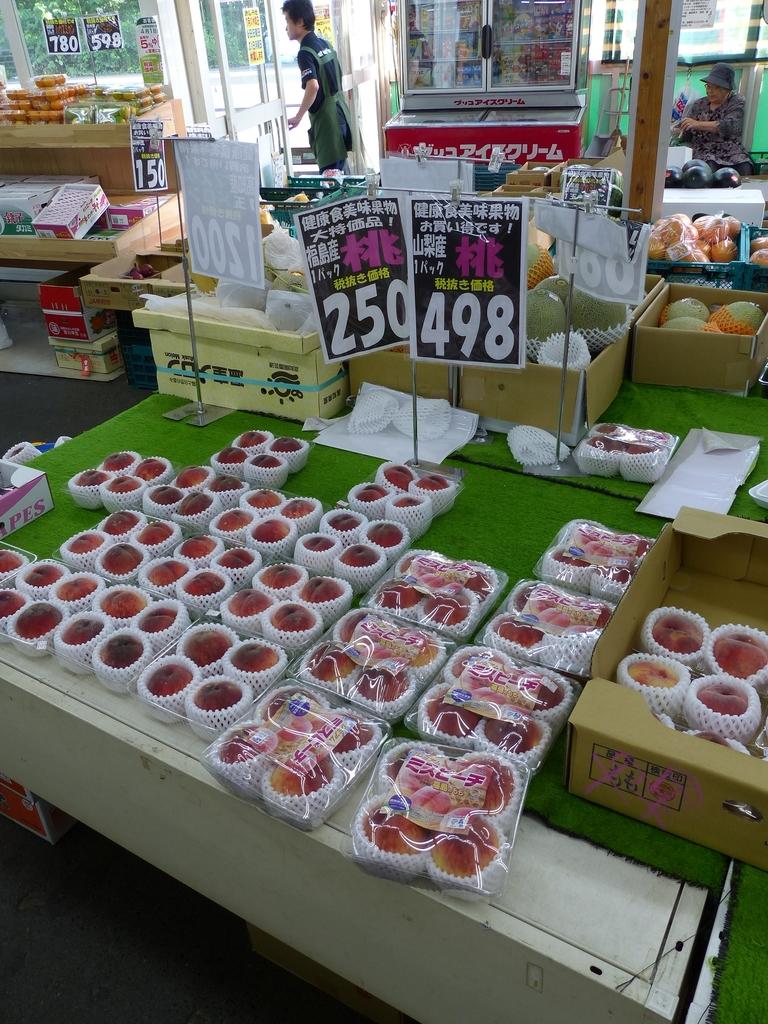What is the price of the fruit on the sign on the right?
Provide a short and direct response. 498. What's the number on the far left sign, in the window?
Provide a short and direct response. 780. 